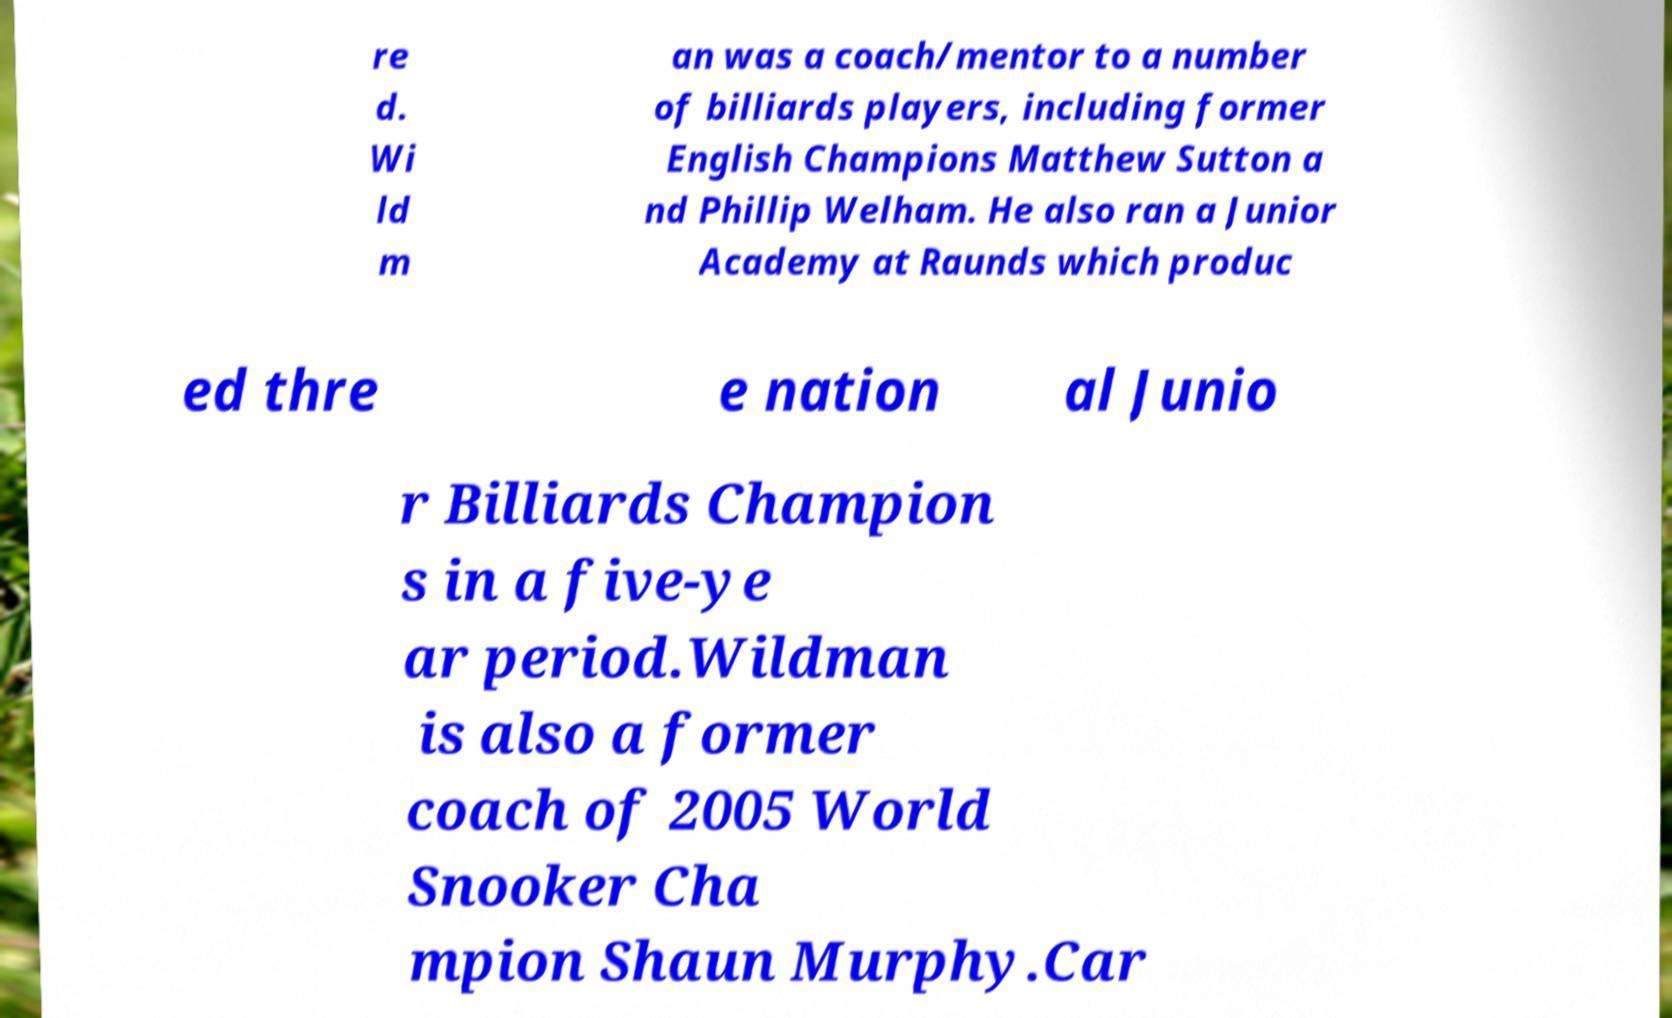Please read and relay the text visible in this image. What does it say? re d. Wi ld m an was a coach/mentor to a number of billiards players, including former English Champions Matthew Sutton a nd Phillip Welham. He also ran a Junior Academy at Raunds which produc ed thre e nation al Junio r Billiards Champion s in a five-ye ar period.Wildman is also a former coach of 2005 World Snooker Cha mpion Shaun Murphy.Car 